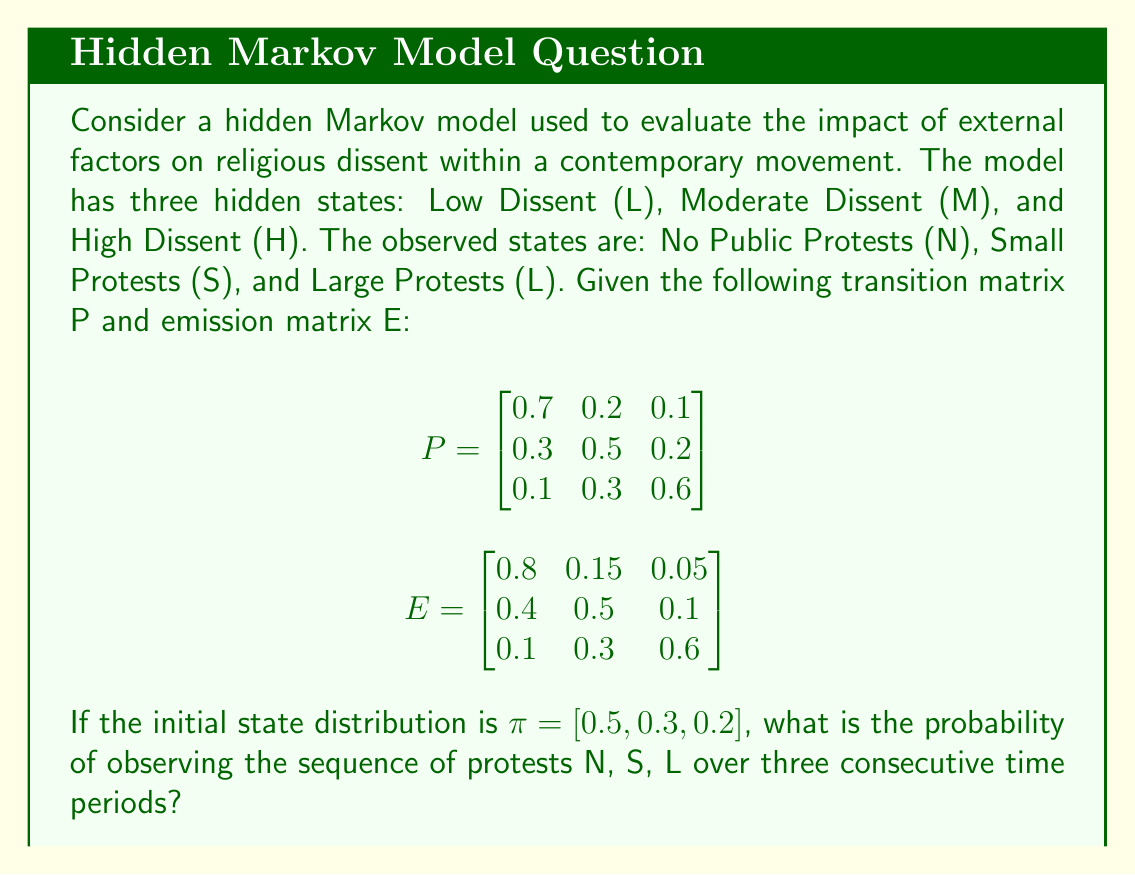Give your solution to this math problem. To solve this problem, we'll use the forward algorithm for hidden Markov models. Let's break it down step-by-step:

1) Define the forward variable $\alpha_t(i)$ as the probability of observing the partial sequence up to time t and being in state i at time t.

2) Initialize the forward variables for t=1:
   $\alpha_1(i) = \pi_i \cdot e_i(O_1)$, where $O_1 = N$
   
   $\alpha_1(L) = 0.5 \cdot 0.8 = 0.4$
   $\alpha_1(M) = 0.3 \cdot 0.4 = 0.12$
   $\alpha_1(H) = 0.2 \cdot 0.1 = 0.02$

3) Recursively compute $\alpha_t(j)$ for t=2 and t=3:
   $\alpha_t(j) = [\sum_{i=1}^N \alpha_{t-1}(i) \cdot p_{ij}] \cdot e_j(O_t)$

   For t=2, $O_2 = S$:
   $\alpha_2(L) = [(0.4 \cdot 0.7 + 0.12 \cdot 0.3 + 0.02 \cdot 0.1) \cdot 0.15] = 0.04635$
   $\alpha_2(M) = [(0.4 \cdot 0.2 + 0.12 \cdot 0.5 + 0.02 \cdot 0.3) \cdot 0.5] = 0.0565$
   $\alpha_2(H) = [(0.4 \cdot 0.1 + 0.12 \cdot 0.2 + 0.02 \cdot 0.6) \cdot 0.3] = 0.01596$

   For t=3, $O_3 = L$:
   $\alpha_3(L) = [(0.04635 \cdot 0.7 + 0.0565 \cdot 0.3 + 0.01596 \cdot 0.1) \cdot 0.05] = 0.001915$
   $\alpha_3(M) = [(0.04635 \cdot 0.2 + 0.0565 \cdot 0.5 + 0.01596 \cdot 0.3) \cdot 0.1] = 0.000915$
   $\alpha_3(H) = [(0.04635 \cdot 0.1 + 0.0565 \cdot 0.2 + 0.01596 \cdot 0.6) \cdot 0.6] = 0.007374$

4) The probability of the entire sequence is the sum of the final forward variables:
   $P(O_1, O_2, O_3) = \sum_{i=1}^N \alpha_3(i) = 0.001915 + 0.000915 + 0.007374 = 0.010204$
Answer: 0.010204 